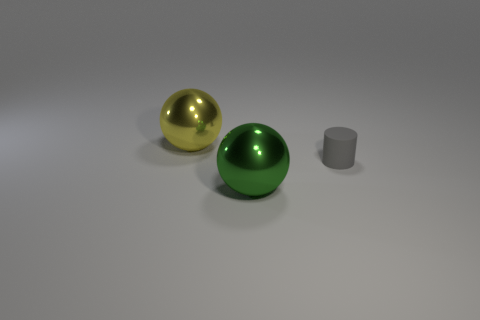Add 2 big purple shiny objects. How many objects exist? 5 Subtract 2 balls. How many balls are left? 0 Subtract all green balls. How many balls are left? 1 Subtract all large yellow metallic things. Subtract all big cyan cubes. How many objects are left? 2 Add 1 metallic things. How many metallic things are left? 3 Add 1 large brown cylinders. How many large brown cylinders exist? 1 Subtract 0 blue balls. How many objects are left? 3 Subtract all cylinders. How many objects are left? 2 Subtract all cyan balls. Subtract all red blocks. How many balls are left? 2 Subtract all yellow cylinders. How many green balls are left? 1 